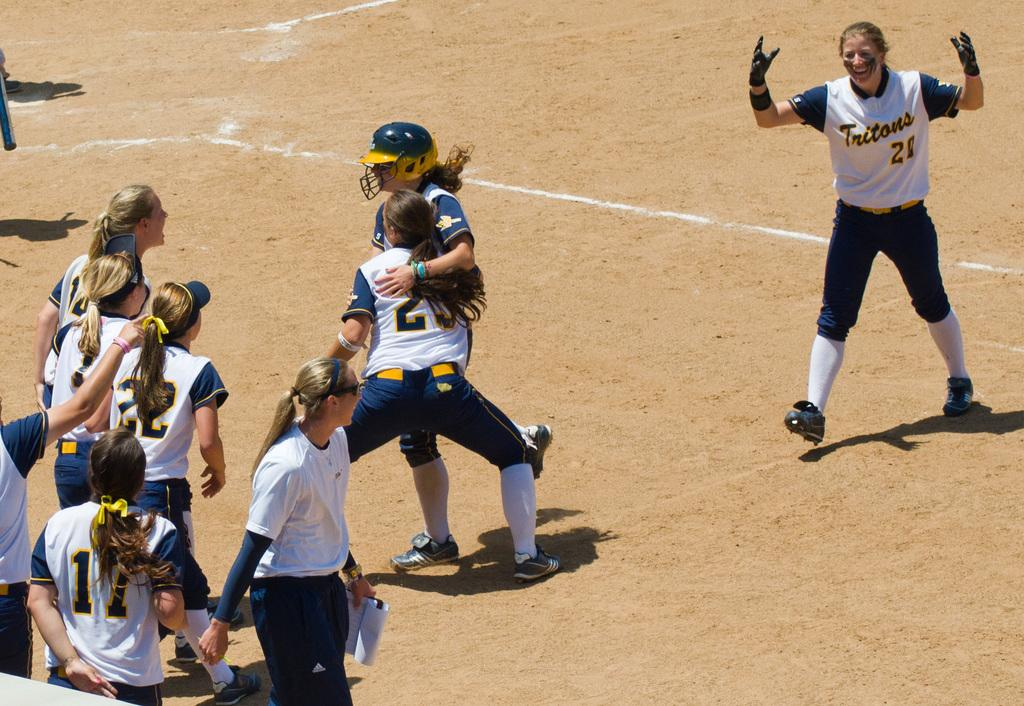<image>
Create a compact narrative representing the image presented. Baseball players for Tritons celebrating after a win. 